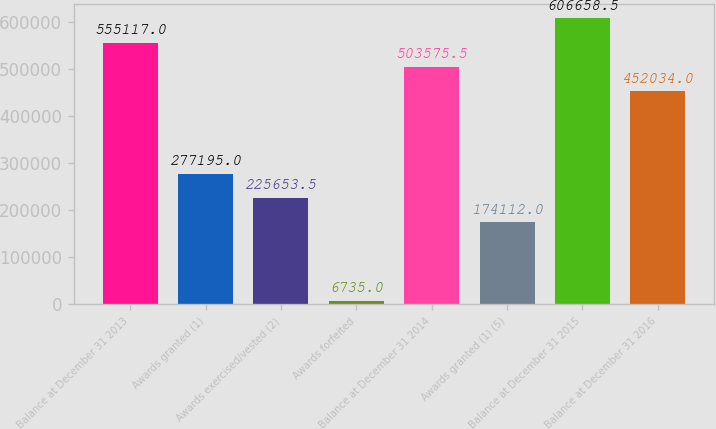Convert chart. <chart><loc_0><loc_0><loc_500><loc_500><bar_chart><fcel>Balance at December 31 2013<fcel>Awards granted (1)<fcel>Awards exercised/vested (2)<fcel>Awards forfeited<fcel>Balance at December 31 2014<fcel>Awards granted (1) (5)<fcel>Balance at December 31 2015<fcel>Balance at December 31 2016<nl><fcel>555117<fcel>277195<fcel>225654<fcel>6735<fcel>503576<fcel>174112<fcel>606658<fcel>452034<nl></chart> 